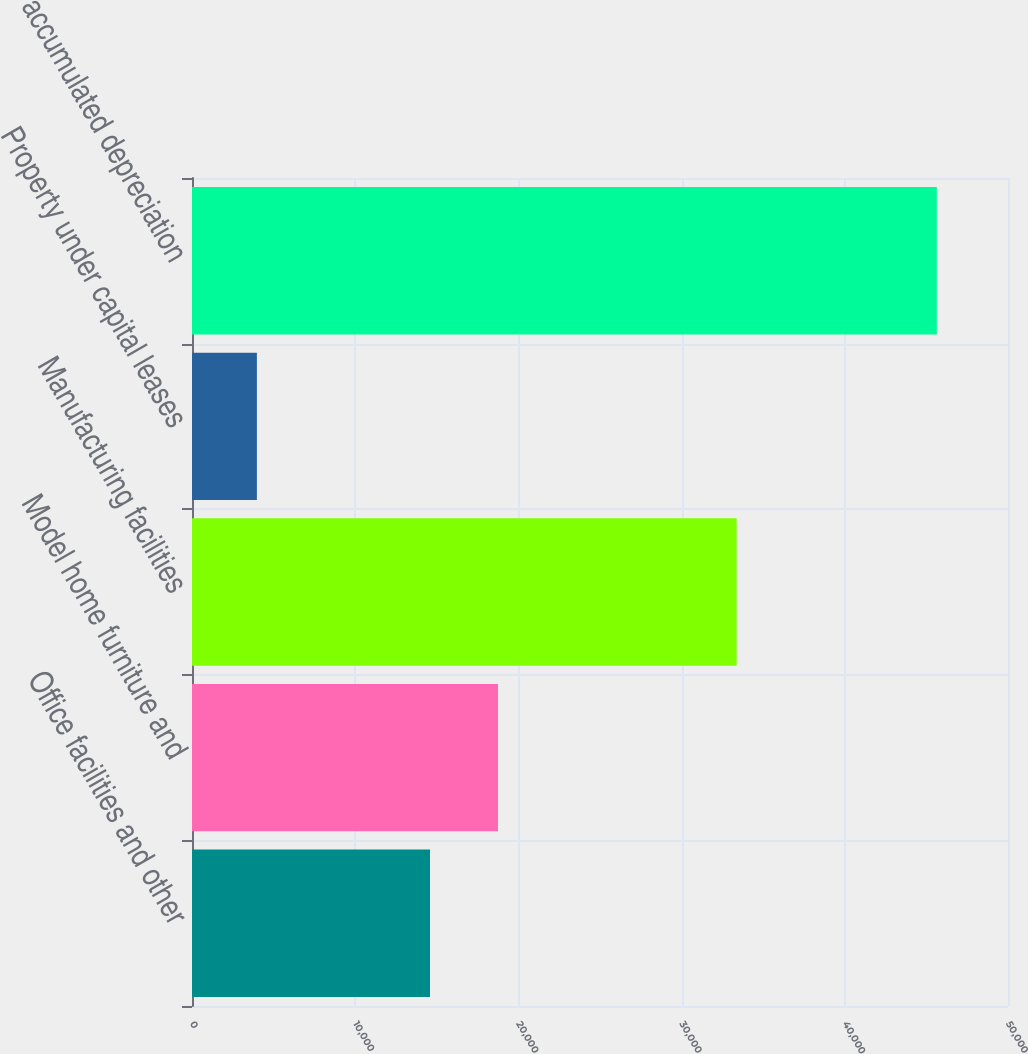<chart> <loc_0><loc_0><loc_500><loc_500><bar_chart><fcel>Office facilities and other<fcel>Model home furniture and<fcel>Manufacturing facilities<fcel>Property under capital leases<fcel>Less accumulated depreciation<nl><fcel>14584<fcel>18750.4<fcel>33373<fcel>3976<fcel>45640<nl></chart> 